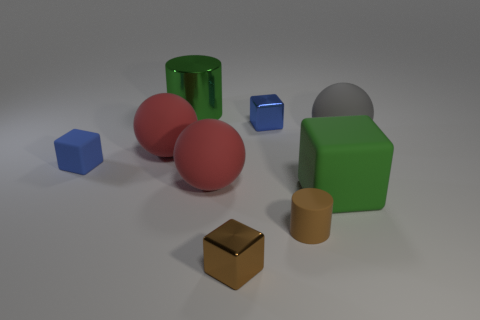Subtract 1 blocks. How many blocks are left? 3 Subtract all yellow cubes. Subtract all green spheres. How many cubes are left? 4 Add 1 brown objects. How many objects exist? 10 Subtract all cubes. How many objects are left? 5 Add 3 large cubes. How many large cubes are left? 4 Add 3 brown matte spheres. How many brown matte spheres exist? 3 Subtract 0 cyan balls. How many objects are left? 9 Subtract all metallic cylinders. Subtract all green matte balls. How many objects are left? 8 